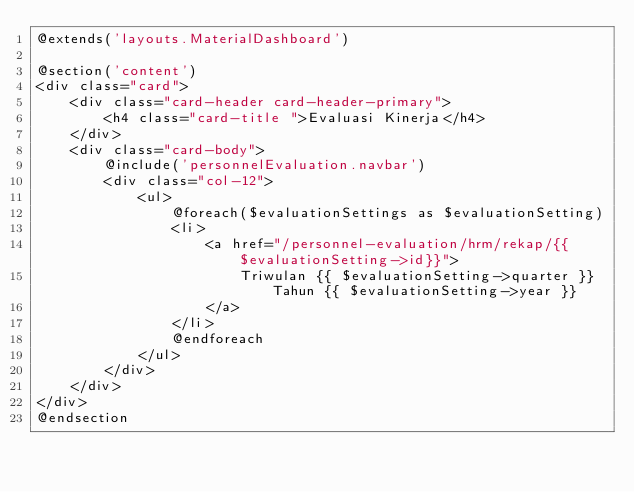Convert code to text. <code><loc_0><loc_0><loc_500><loc_500><_PHP_>@extends('layouts.MaterialDashboard')

@section('content')
<div class="card">
    <div class="card-header card-header-primary">
        <h4 class="card-title ">Evaluasi Kinerja</h4>
    </div>
    <div class="card-body">
        @include('personnelEvaluation.navbar')
        <div class="col-12">
            <ul>
                @foreach($evaluationSettings as $evaluationSetting)
                <li>
                    <a href="/personnel-evaluation/hrm/rekap/{{$evaluationSetting->id}}">
                        Triwulan {{ $evaluationSetting->quarter }} Tahun {{ $evaluationSetting->year }}
                    </a>
                </li>
                @endforeach
            </ul>
        </div>
    </div>
</div>
@endsection
</code> 